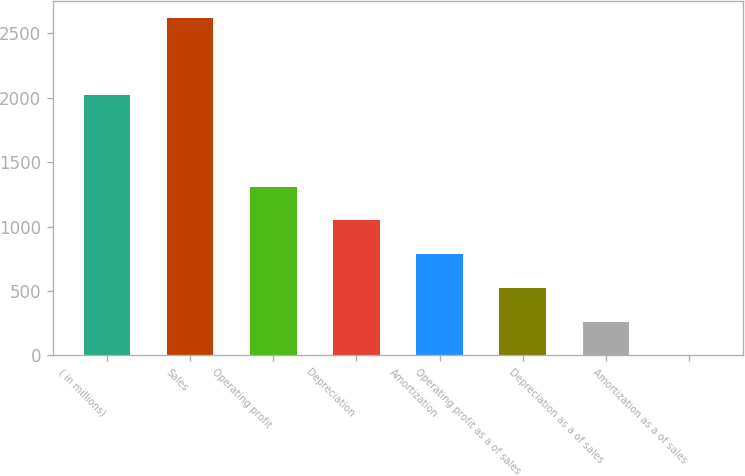<chart> <loc_0><loc_0><loc_500><loc_500><bar_chart><fcel>( in millions)<fcel>Sales<fcel>Operating profit<fcel>Depreciation<fcel>Amortization<fcel>Operating profit as a of sales<fcel>Depreciation as a of sales<fcel>Amortization as a of sales<nl><fcel>2017<fcel>2617<fcel>1309<fcel>1047.4<fcel>785.8<fcel>524.2<fcel>262.6<fcel>1<nl></chart> 